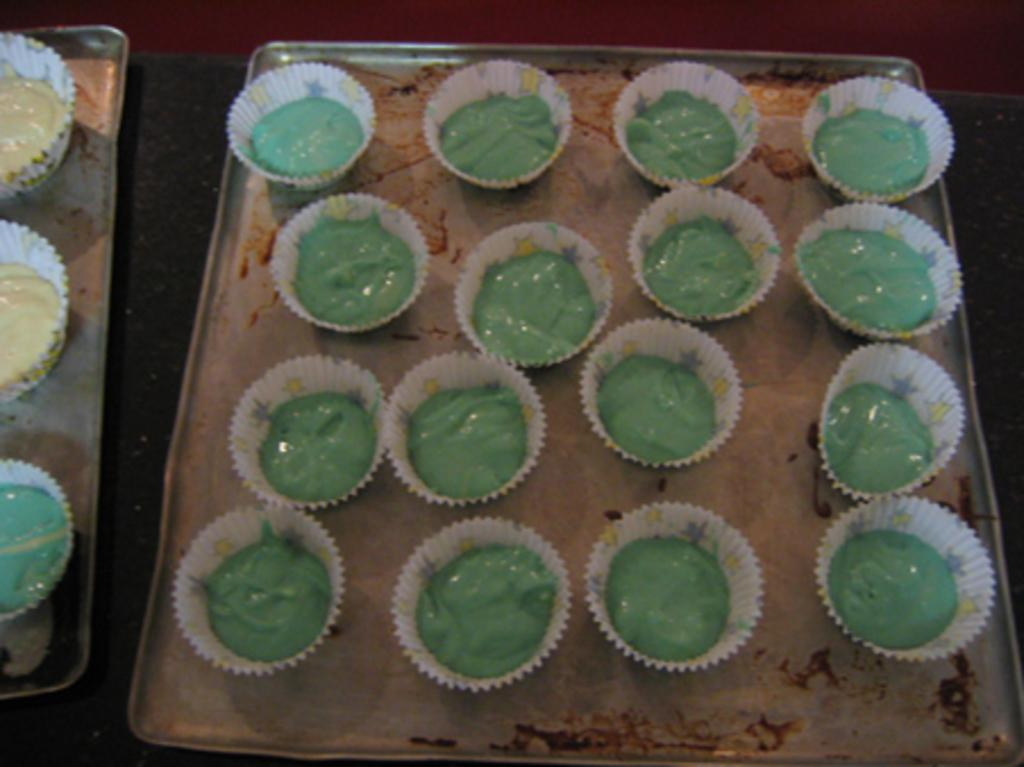What object is the main subject of the image? The main subject of the image is a battery. How are the batteries arranged in the image? The batteries are in paper cups. What are the paper cups placed on in the image? The paper cups are on silver trays. Who is the owner of the deer in the image? There is no deer present in the image, so it is not possible to determine the owner. 